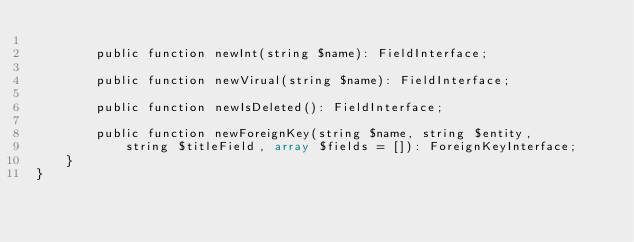Convert code to text. <code><loc_0><loc_0><loc_500><loc_500><_PHP_>
		public function newInt(string $name): FieldInterface;

		public function newVirual(string $name): FieldInterface;

		public function newIsDeleted(): FieldInterface;

		public function newForeignKey(string $name, string $entity,
			string $titleField, array $fields = []): ForeignKeyInterface;
	}
}</code> 